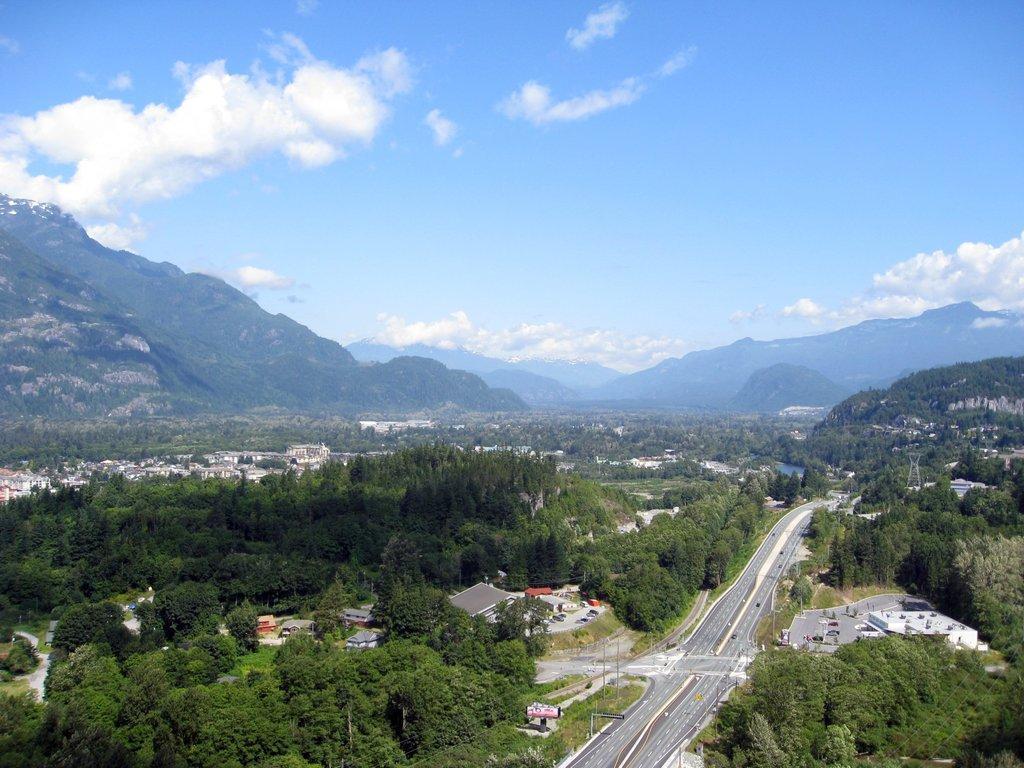Could you give a brief overview of what you see in this image? In this image I can see two roads in the centre and on the both side of it I can see number of trees, few moles and number of buildings. In the background I can see mountains, clouds and the sky. 